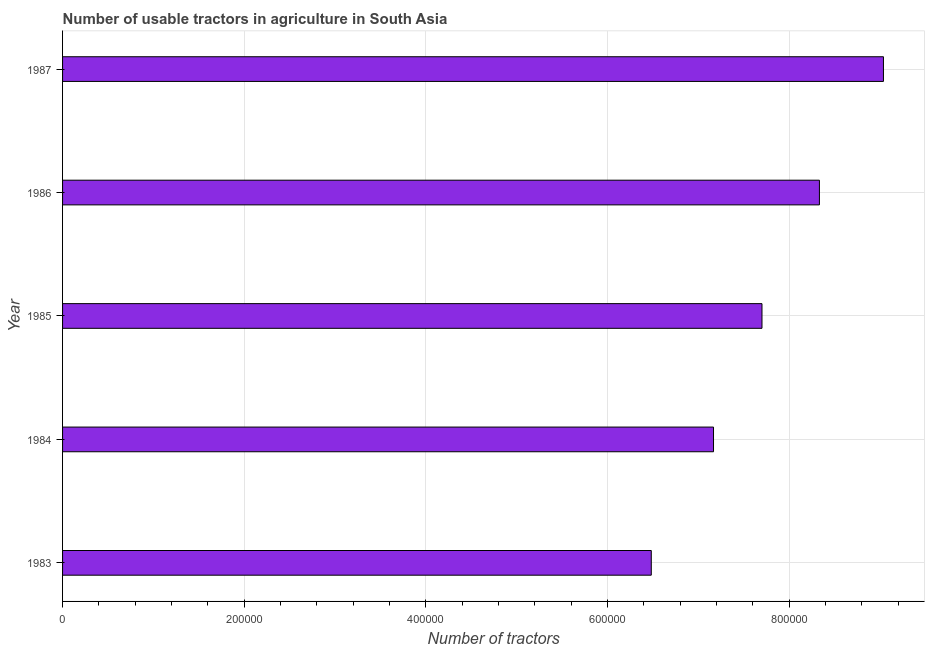What is the title of the graph?
Make the answer very short. Number of usable tractors in agriculture in South Asia. What is the label or title of the X-axis?
Offer a terse response. Number of tractors. What is the label or title of the Y-axis?
Your answer should be very brief. Year. What is the number of tractors in 1985?
Your answer should be compact. 7.70e+05. Across all years, what is the maximum number of tractors?
Your answer should be very brief. 9.04e+05. Across all years, what is the minimum number of tractors?
Offer a very short reply. 6.48e+05. In which year was the number of tractors minimum?
Your answer should be compact. 1983. What is the sum of the number of tractors?
Keep it short and to the point. 3.87e+06. What is the difference between the number of tractors in 1983 and 1986?
Give a very brief answer. -1.85e+05. What is the average number of tractors per year?
Provide a short and direct response. 7.74e+05. What is the median number of tractors?
Provide a succinct answer. 7.70e+05. What is the ratio of the number of tractors in 1984 to that in 1986?
Provide a short and direct response. 0.86. Is the number of tractors in 1983 less than that in 1987?
Ensure brevity in your answer.  Yes. Is the difference between the number of tractors in 1983 and 1985 greater than the difference between any two years?
Your answer should be compact. No. What is the difference between the highest and the second highest number of tractors?
Offer a terse response. 7.05e+04. What is the difference between the highest and the lowest number of tractors?
Your answer should be compact. 2.56e+05. In how many years, is the number of tractors greater than the average number of tractors taken over all years?
Your answer should be compact. 2. Are all the bars in the graph horizontal?
Your answer should be compact. Yes. What is the difference between two consecutive major ticks on the X-axis?
Make the answer very short. 2.00e+05. Are the values on the major ticks of X-axis written in scientific E-notation?
Provide a succinct answer. No. What is the Number of tractors in 1983?
Provide a succinct answer. 6.48e+05. What is the Number of tractors in 1984?
Offer a terse response. 7.17e+05. What is the Number of tractors in 1985?
Give a very brief answer. 7.70e+05. What is the Number of tractors of 1986?
Keep it short and to the point. 8.33e+05. What is the Number of tractors in 1987?
Your answer should be very brief. 9.04e+05. What is the difference between the Number of tractors in 1983 and 1984?
Keep it short and to the point. -6.85e+04. What is the difference between the Number of tractors in 1983 and 1985?
Offer a very short reply. -1.22e+05. What is the difference between the Number of tractors in 1983 and 1986?
Your response must be concise. -1.85e+05. What is the difference between the Number of tractors in 1983 and 1987?
Offer a terse response. -2.56e+05. What is the difference between the Number of tractors in 1984 and 1985?
Your response must be concise. -5.34e+04. What is the difference between the Number of tractors in 1984 and 1986?
Provide a succinct answer. -1.17e+05. What is the difference between the Number of tractors in 1984 and 1987?
Your answer should be compact. -1.87e+05. What is the difference between the Number of tractors in 1985 and 1986?
Offer a very short reply. -6.32e+04. What is the difference between the Number of tractors in 1985 and 1987?
Your answer should be very brief. -1.34e+05. What is the difference between the Number of tractors in 1986 and 1987?
Offer a terse response. -7.05e+04. What is the ratio of the Number of tractors in 1983 to that in 1984?
Make the answer very short. 0.9. What is the ratio of the Number of tractors in 1983 to that in 1985?
Offer a terse response. 0.84. What is the ratio of the Number of tractors in 1983 to that in 1986?
Offer a very short reply. 0.78. What is the ratio of the Number of tractors in 1983 to that in 1987?
Offer a terse response. 0.72. What is the ratio of the Number of tractors in 1984 to that in 1985?
Give a very brief answer. 0.93. What is the ratio of the Number of tractors in 1984 to that in 1986?
Provide a short and direct response. 0.86. What is the ratio of the Number of tractors in 1984 to that in 1987?
Your response must be concise. 0.79. What is the ratio of the Number of tractors in 1985 to that in 1986?
Ensure brevity in your answer.  0.92. What is the ratio of the Number of tractors in 1985 to that in 1987?
Make the answer very short. 0.85. What is the ratio of the Number of tractors in 1986 to that in 1987?
Keep it short and to the point. 0.92. 